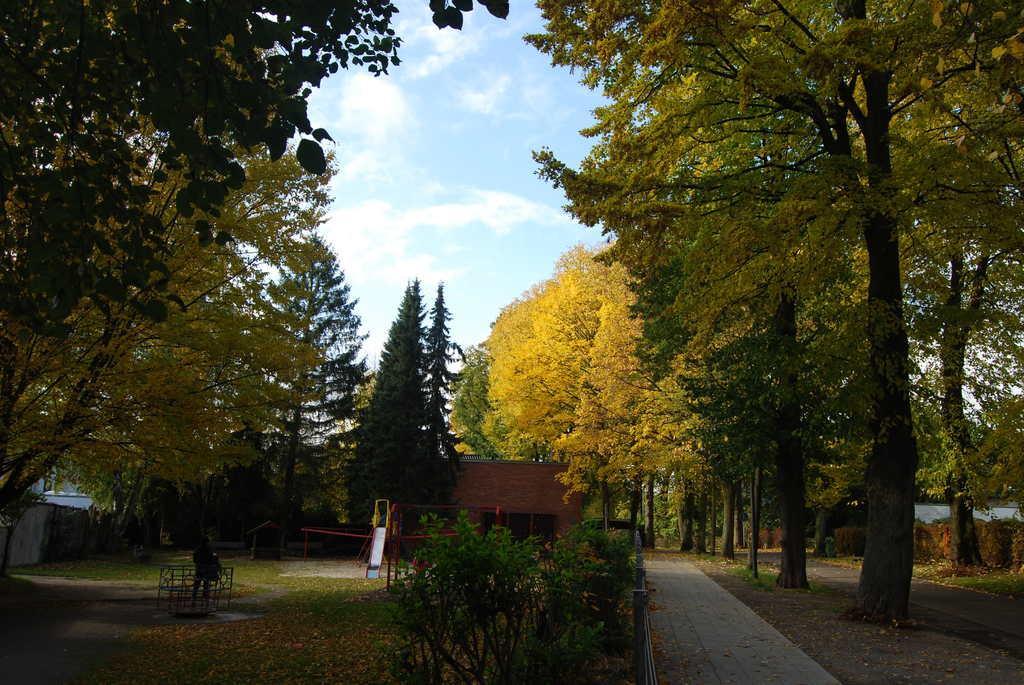Describe this image in one or two sentences. In this picture I can see a house, there are plants, trees, and in the background there is the sky. 